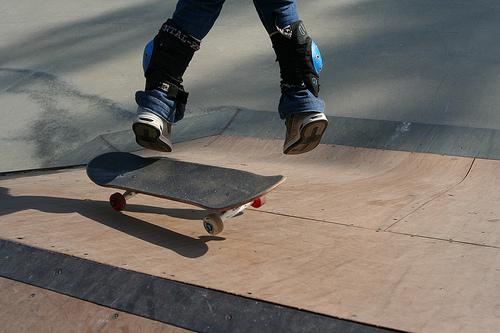Question: what is the man doing?
Choices:
A. Sitting.
B. Running.
C. Jumping.
D. Sleeping.
Answer with the letter. Answer: C Question: what color is the man's board?
Choices:
A. White.
B. Pink.
C. Black.
D. Green.
Answer with the letter. Answer: C Question: when was the photo taken?
Choices:
A. Day time.
B. At night.
C. Sunrise.
D. Noon.
Answer with the letter. Answer: A Question: why is the man jumping?
Choices:
A. Doing a trick.
B. To avoid a snake.
C. A hurdle.
D. For fun.
Answer with the letter. Answer: A Question: where was the photo taken?
Choices:
A. Skatepark.
B. A museum.
C. A park.
D. The ocean.
Answer with the letter. Answer: A 